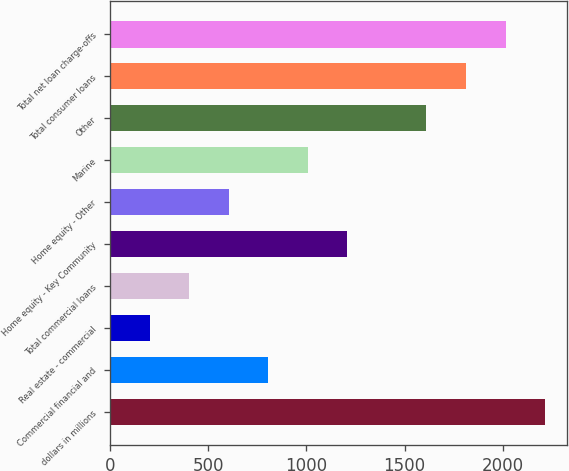Convert chart to OTSL. <chart><loc_0><loc_0><loc_500><loc_500><bar_chart><fcel>dollars in millions<fcel>Commercial financial and<fcel>Real estate - commercial<fcel>Total commercial loans<fcel>Home equity - Key Community<fcel>Home equity - Other<fcel>Marine<fcel>Other<fcel>Total consumer loans<fcel>Total net loan charge-offs<nl><fcel>2215.38<fcel>805.72<fcel>201.58<fcel>402.96<fcel>1208.48<fcel>604.34<fcel>1007.1<fcel>1611.24<fcel>1812.62<fcel>2014<nl></chart> 